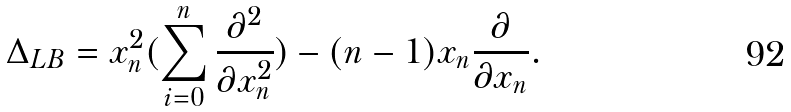<formula> <loc_0><loc_0><loc_500><loc_500>\Delta _ { L B } = x _ { n } ^ { 2 } ( \sum _ { i = 0 } ^ { n } \frac { \partial ^ { 2 } } { \partial x _ { n } ^ { 2 } } ) - ( n - 1 ) x _ { n } \frac { \partial } { \partial x _ { n } } .</formula> 